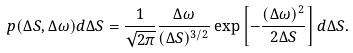<formula> <loc_0><loc_0><loc_500><loc_500>p ( \Delta S , \Delta \omega ) d \Delta S = \frac { 1 } { \sqrt { 2 \pi } } \frac { \Delta \omega } { ( \Delta S ) ^ { 3 / 2 } } \exp \left [ - \frac { ( \Delta \omega ) ^ { 2 } } { 2 \Delta S } \right ] d \Delta S .</formula> 